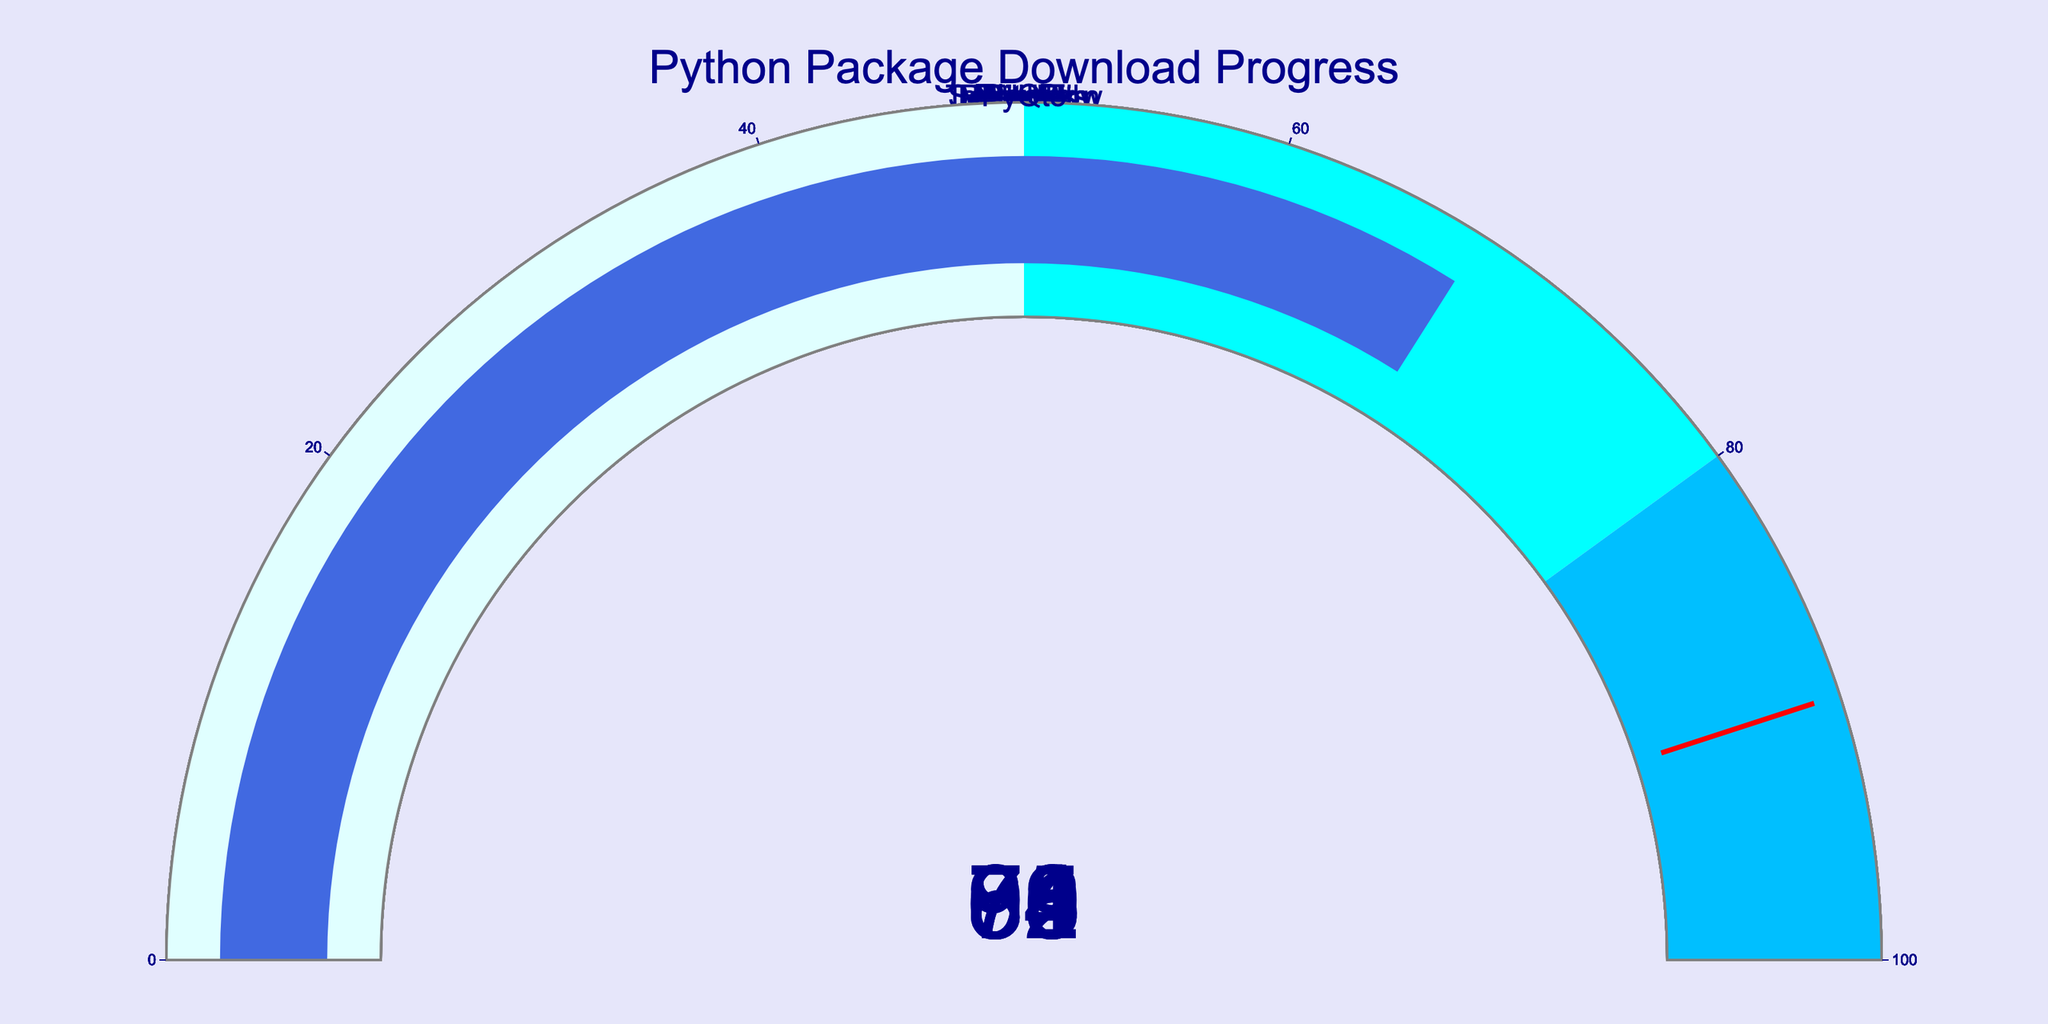What's the download progress of the TensorFlow package? Look at the gauge chart labeled "TensorFlow" and note the value.
Answer: 63 Which package has the highest download progress? Compare the values on all the gauges to find the package with the highest value. Pillow shows the highest download progress at 94%.
Answer: Pillow What is the average download progress of all packages? Sum all the values and divide by the number of packages: (85 + 92 + 78 + 63 + 71 + 89 + 76 + 82 + 94 + 68) / 10 = 79.8
Answer: 79.8 How many packages have a download progress greater than 80%? Count the number of gauges showing values greater than 80. NumPy, Pandas, Django, Scikit-learn, and Pillow all have progress greater than 80%.
Answer: 5 Which package has a download progress closest to 75%? Compare the values and find the one closest to 75. Flask has a progress of 76% which is closest to 75%.
Answer: Flask Among NumPy, Request, and Matplotlib, which package has the lowest download progress? Compare the gauges for NumPy, Requests, and Matplotlib and identify the smallest value. Requests has the lowest progress at 78%.
Answer: Requests Calculate the range of download progress values. Determine the difference between the highest and lowest values: 94 (Pillow) - 63 (TensorFlow) = 31
Answer: 31 Which package's download progress exceeds the threshold value marked by a red line? Identify the packages with download progress values above 90 (threshold value). Pandas and Pillow exceed the threshold.
Answer: Pandas, Pillow 